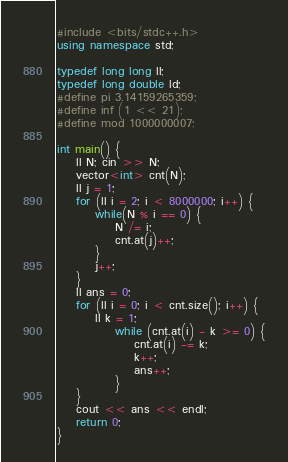Convert code to text. <code><loc_0><loc_0><loc_500><loc_500><_C++_>#include <bits/stdc++.h>
using namespace std;

typedef long long ll;
typedef long double ld;
#define pi 3.14159265359;
#define inf (1 << 21);
#define mod 1000000007;

int main() {
    ll N; cin >> N;
    vector<int> cnt(N);
    ll j = 1;
    for (ll i = 2; i < 8000000; i++) {
        while(N % i == 0) {
            N /= i;
            cnt.at(j)++;
        }
        j++;
    }
    ll ans = 0;
    for (ll i = 0; i < cnt.size(); i++) {
        ll k = 1;
            while (cnt.at(i) - k >= 0) {
                cnt.at(i) -= k;
                k++;
                ans++;
            }
    }
    cout << ans << endl;
    return 0;
}</code> 